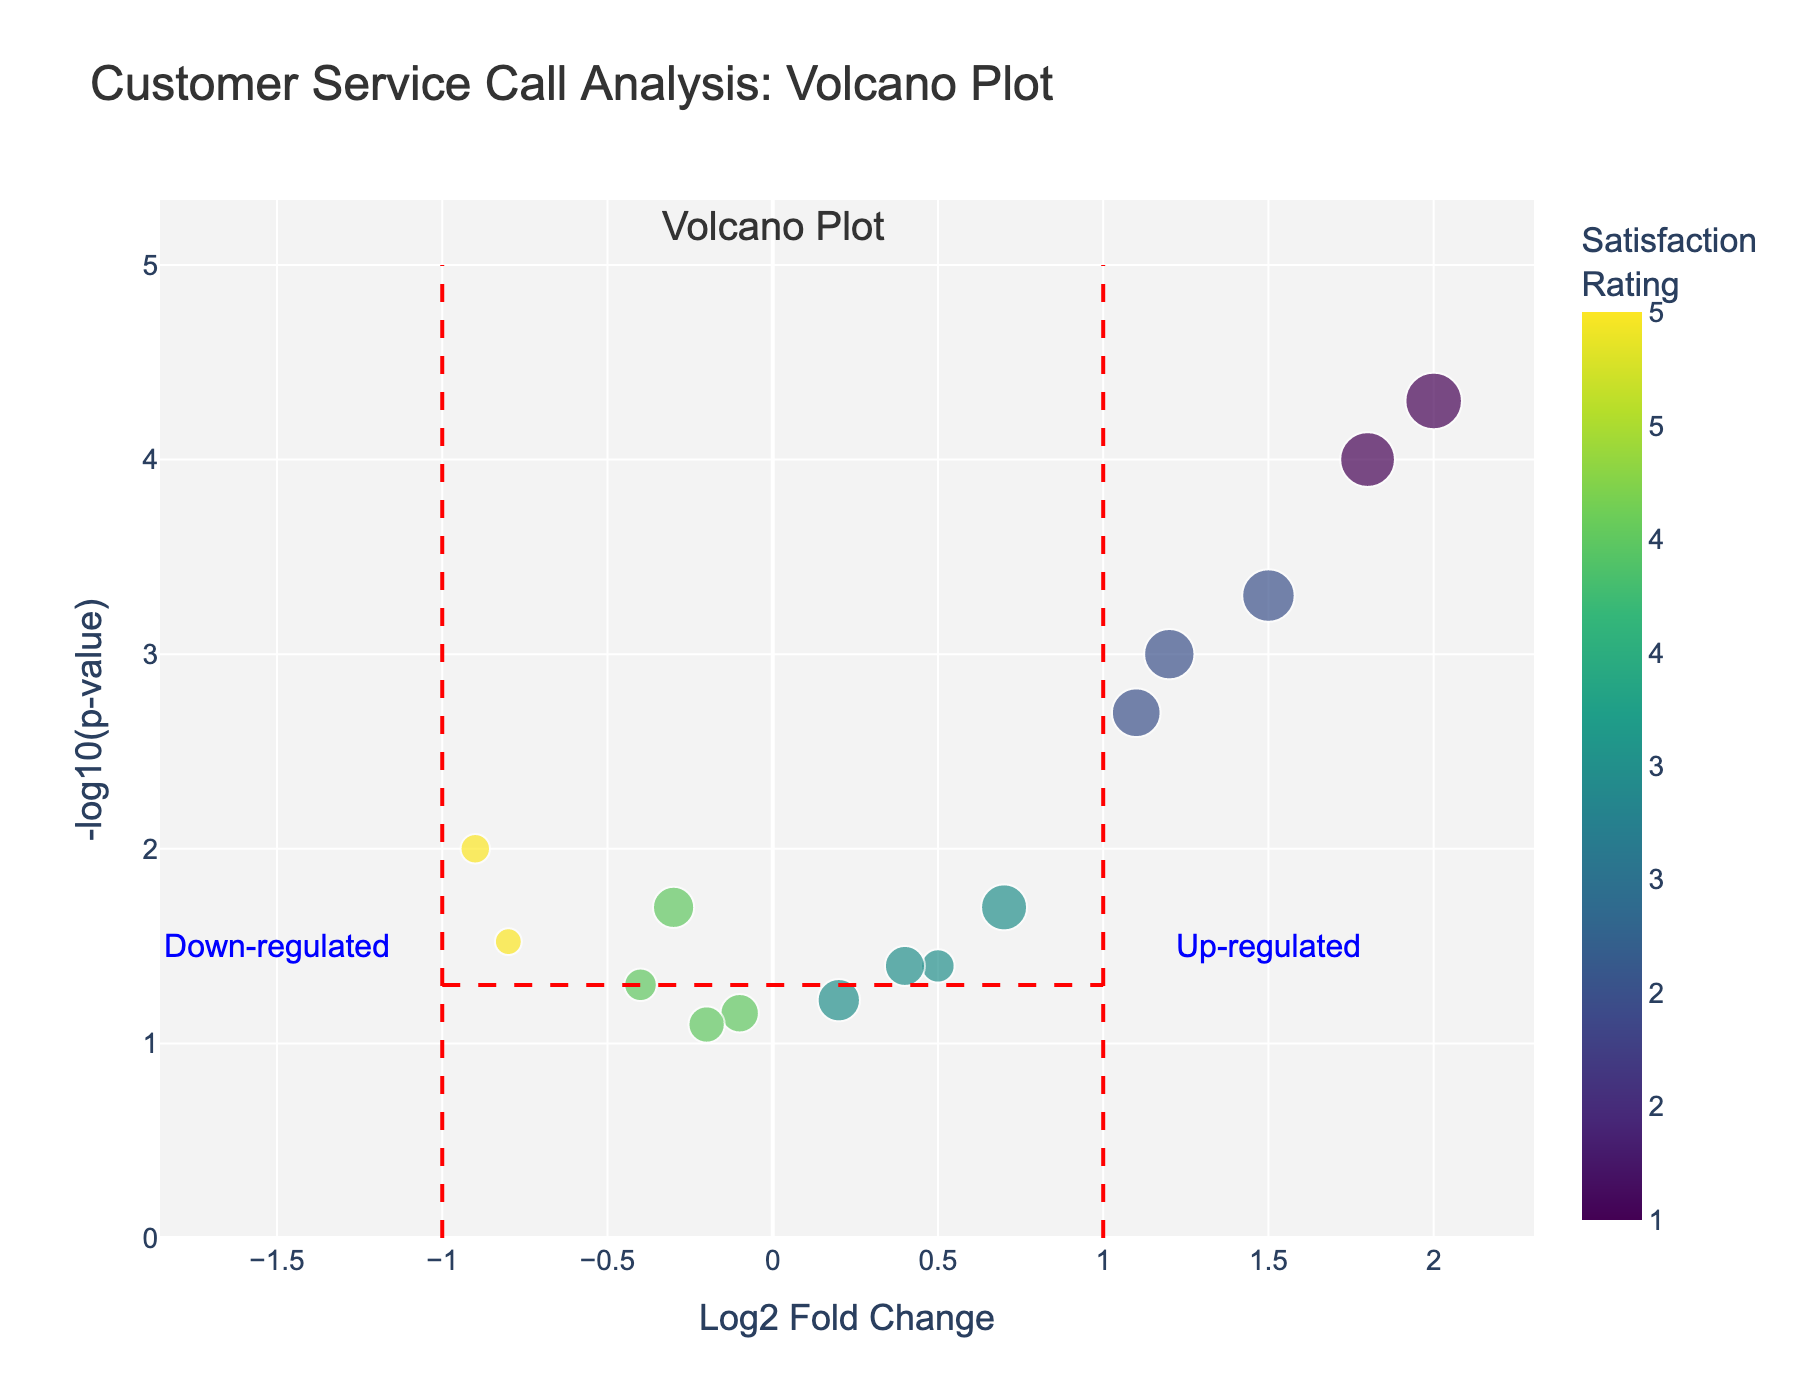What is the title of the figure? The title of the figure is at the top and reads "Customer Service Call Analysis: Volcano Plot".
Answer: Customer Service Call Analysis: Volcano Plot What does the x-axis represent? The x-axis label is "Log2 Fold Change", which represents the log2 fold change in customer satisfaction ratings.
Answer: Log2 Fold Change What's the duration and satisfaction rating of the point with a Log2 Fold Change of 1.5? By referring to the hover data for the point at Log2 Fold Change of 1.5, the duration is 20.3 minutes and the satisfaction rating is 2.
Answer: 20.3 minutes, 2 How many calls have a P Value less than 0.001? Points located higher on the y-axis have a lower P Value. The points above the horizontal red dashed line at -log10(p-value) of 3 (which equals a P Value of 0.001) can be counted. These are the data points for calls CS005, CS009, and CS015.
Answer: 3 Which call has the longest duration? By comparing the sizes of the points, larger points indicate longer call durations. The largest point on the plot corresponds to call CS015 with a duration of 23.6 minutes.
Answer: CS015 Which call IDs fall into the up-regulated region according to the plot's annotations? The up-regulated region is to the right of the vertical red dashed line at Log2 Fold Change of 1. The call IDs falling here are CS003, CS005, CS009, CS013, and CS015 based on their Log2 Fold Change values being greater than 1.
Answer: CS003, CS005, CS009, CS013, CS015 What is the highest satisfaction rating and which calls have it? Points with satisfaction ratings of 5 are color-coded and are highest on the plot's color scale. Calls CS004 and CS010 are color-coded for a satisfaction rating of 5.
Answer: 5, CS004 and CS010 What's the relationship between call duration and satisfaction rating for down-regulated calls? Down-regulated calls are to the left of the vertical red dashed line at Log2 Fold Change of -1. By looking at the sizes and colors of these points, shorter durations generally have higher satisfaction ratings, and longer durations have lower satisfaction ratings (e.g., CS004 and CS010 have high satisfaction and short duration, CS005 and CS015 have lower satisfaction and longer duration).
Answer: Shorter durations generally have higher satisfaction ratings Which call has the smallest P Value and what are its Log2 Fold Change and satisfaction rating? The smallest P Value corresponds to the point highest on the y-axis. This is call CS015, which has a Log2 Fold Change of 2.0 and a satisfaction rating of 1.
Answer: CS015, Log2 Fold Change 2.0, Satisfaction Rating 1 